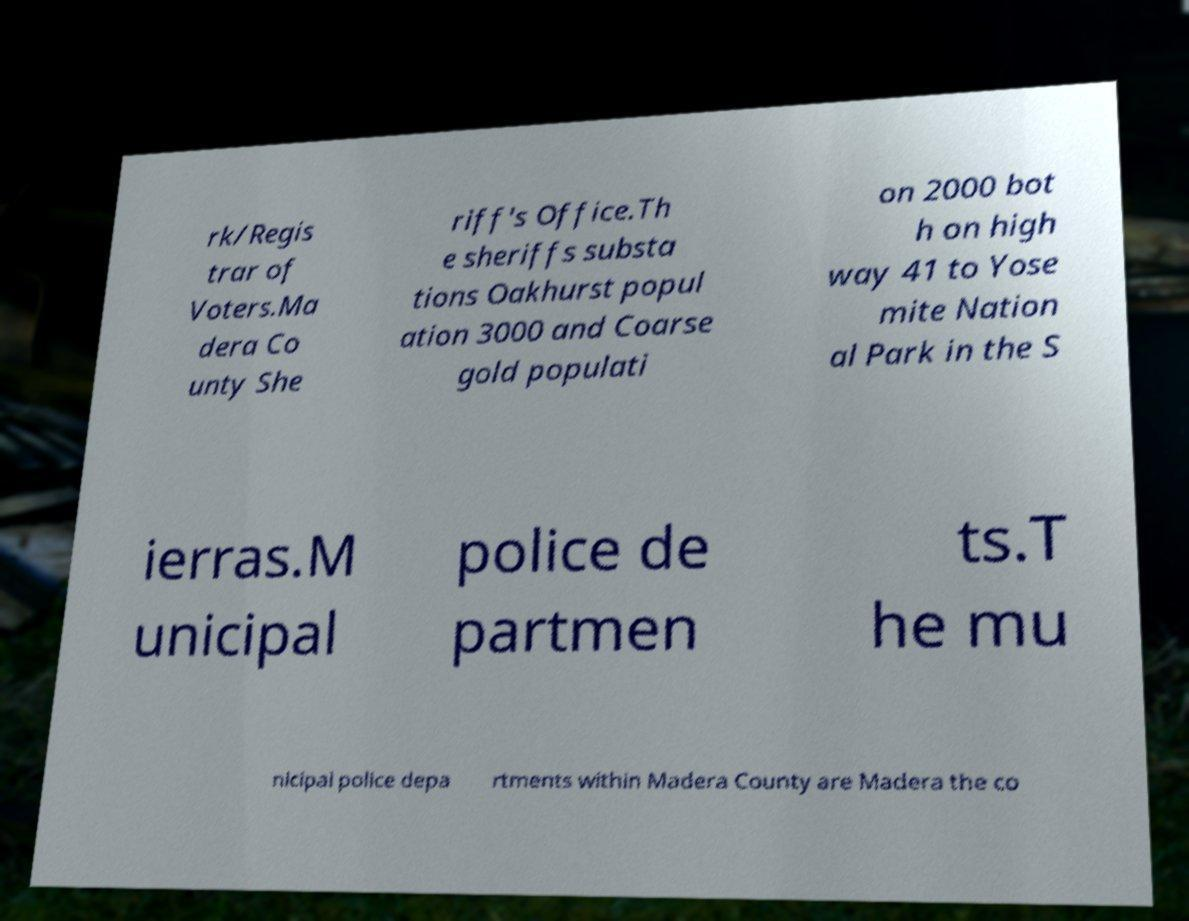Can you read and provide the text displayed in the image?This photo seems to have some interesting text. Can you extract and type it out for me? rk/Regis trar of Voters.Ma dera Co unty She riff's Office.Th e sheriffs substa tions Oakhurst popul ation 3000 and Coarse gold populati on 2000 bot h on high way 41 to Yose mite Nation al Park in the S ierras.M unicipal police de partmen ts.T he mu nicipal police depa rtments within Madera County are Madera the co 